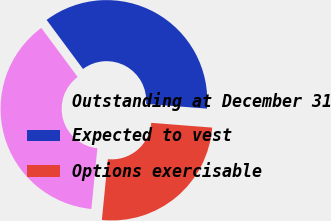Convert chart to OTSL. <chart><loc_0><loc_0><loc_500><loc_500><pie_chart><fcel>Outstanding at December 31<fcel>Expected to vest<fcel>Options exercisable<nl><fcel>38.28%<fcel>36.4%<fcel>25.33%<nl></chart> 